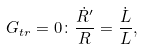Convert formula to latex. <formula><loc_0><loc_0><loc_500><loc_500>G _ { t r } = 0 \colon \frac { { \dot { R } } ^ { \prime } } R = \frac { \dot { L } } L ,</formula> 